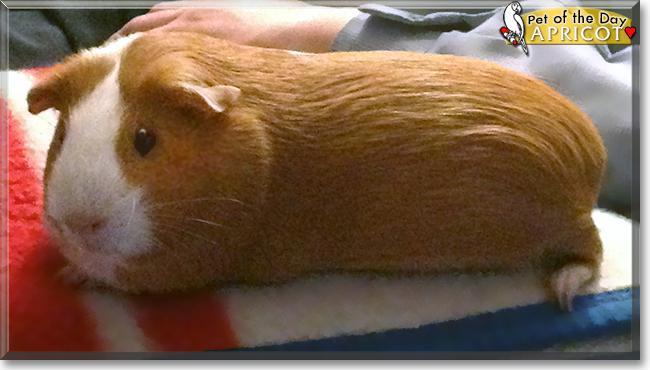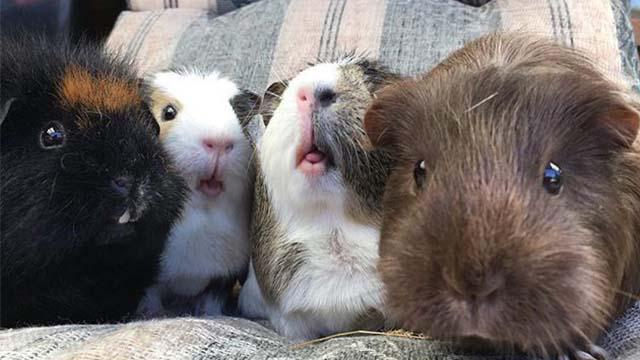The first image is the image on the left, the second image is the image on the right. For the images shown, is this caption "There are two hamsters." true? Answer yes or no. No. 